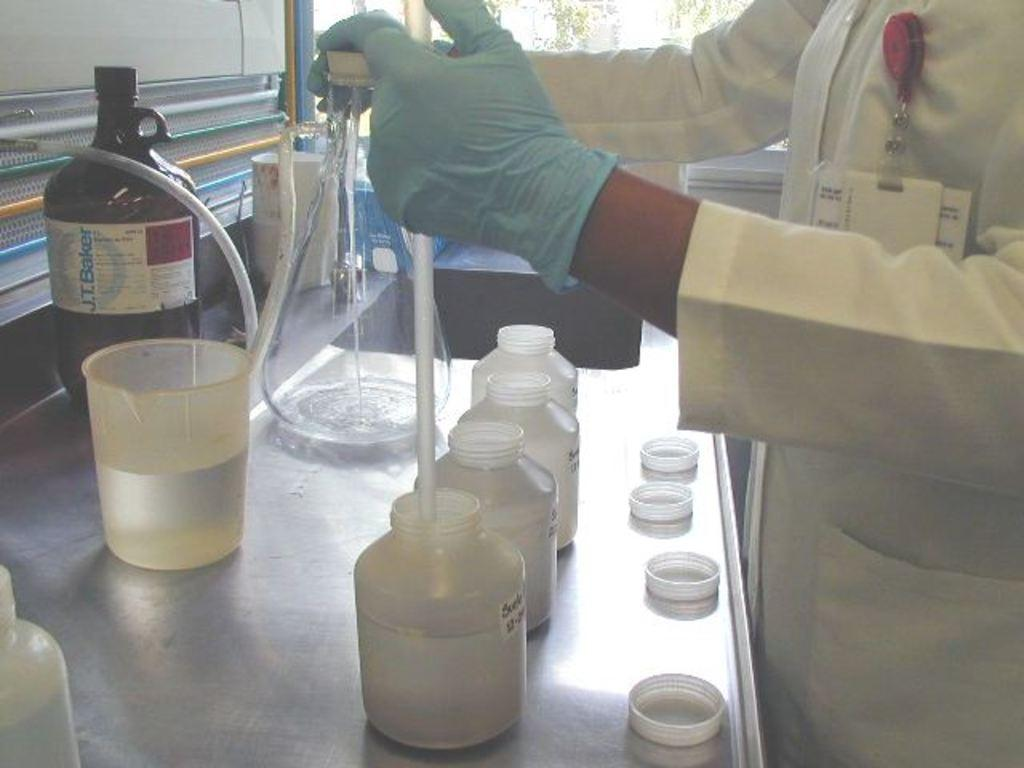<image>
Describe the image concisely. a bottle that says 'j.t.baker' on it on the label 